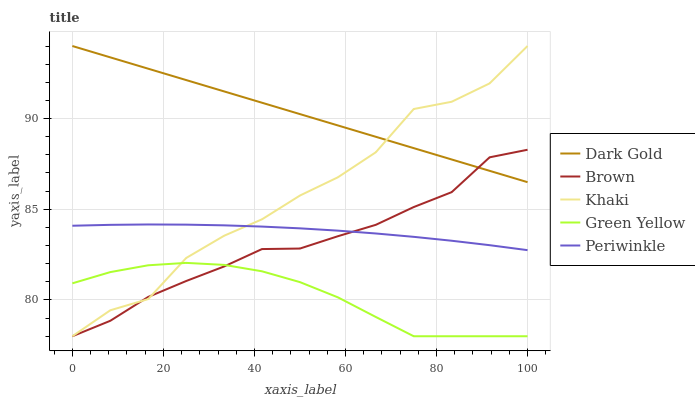Does Green Yellow have the minimum area under the curve?
Answer yes or no. Yes. Does Dark Gold have the maximum area under the curve?
Answer yes or no. Yes. Does Khaki have the minimum area under the curve?
Answer yes or no. No. Does Khaki have the maximum area under the curve?
Answer yes or no. No. Is Dark Gold the smoothest?
Answer yes or no. Yes. Is Khaki the roughest?
Answer yes or no. Yes. Is Green Yellow the smoothest?
Answer yes or no. No. Is Green Yellow the roughest?
Answer yes or no. No. Does Brown have the lowest value?
Answer yes or no. Yes. Does Periwinkle have the lowest value?
Answer yes or no. No. Does Dark Gold have the highest value?
Answer yes or no. Yes. Does Green Yellow have the highest value?
Answer yes or no. No. Is Periwinkle less than Dark Gold?
Answer yes or no. Yes. Is Dark Gold greater than Periwinkle?
Answer yes or no. Yes. Does Dark Gold intersect Khaki?
Answer yes or no. Yes. Is Dark Gold less than Khaki?
Answer yes or no. No. Is Dark Gold greater than Khaki?
Answer yes or no. No. Does Periwinkle intersect Dark Gold?
Answer yes or no. No. 